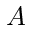<formula> <loc_0><loc_0><loc_500><loc_500>A</formula> 